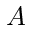<formula> <loc_0><loc_0><loc_500><loc_500>A</formula> 